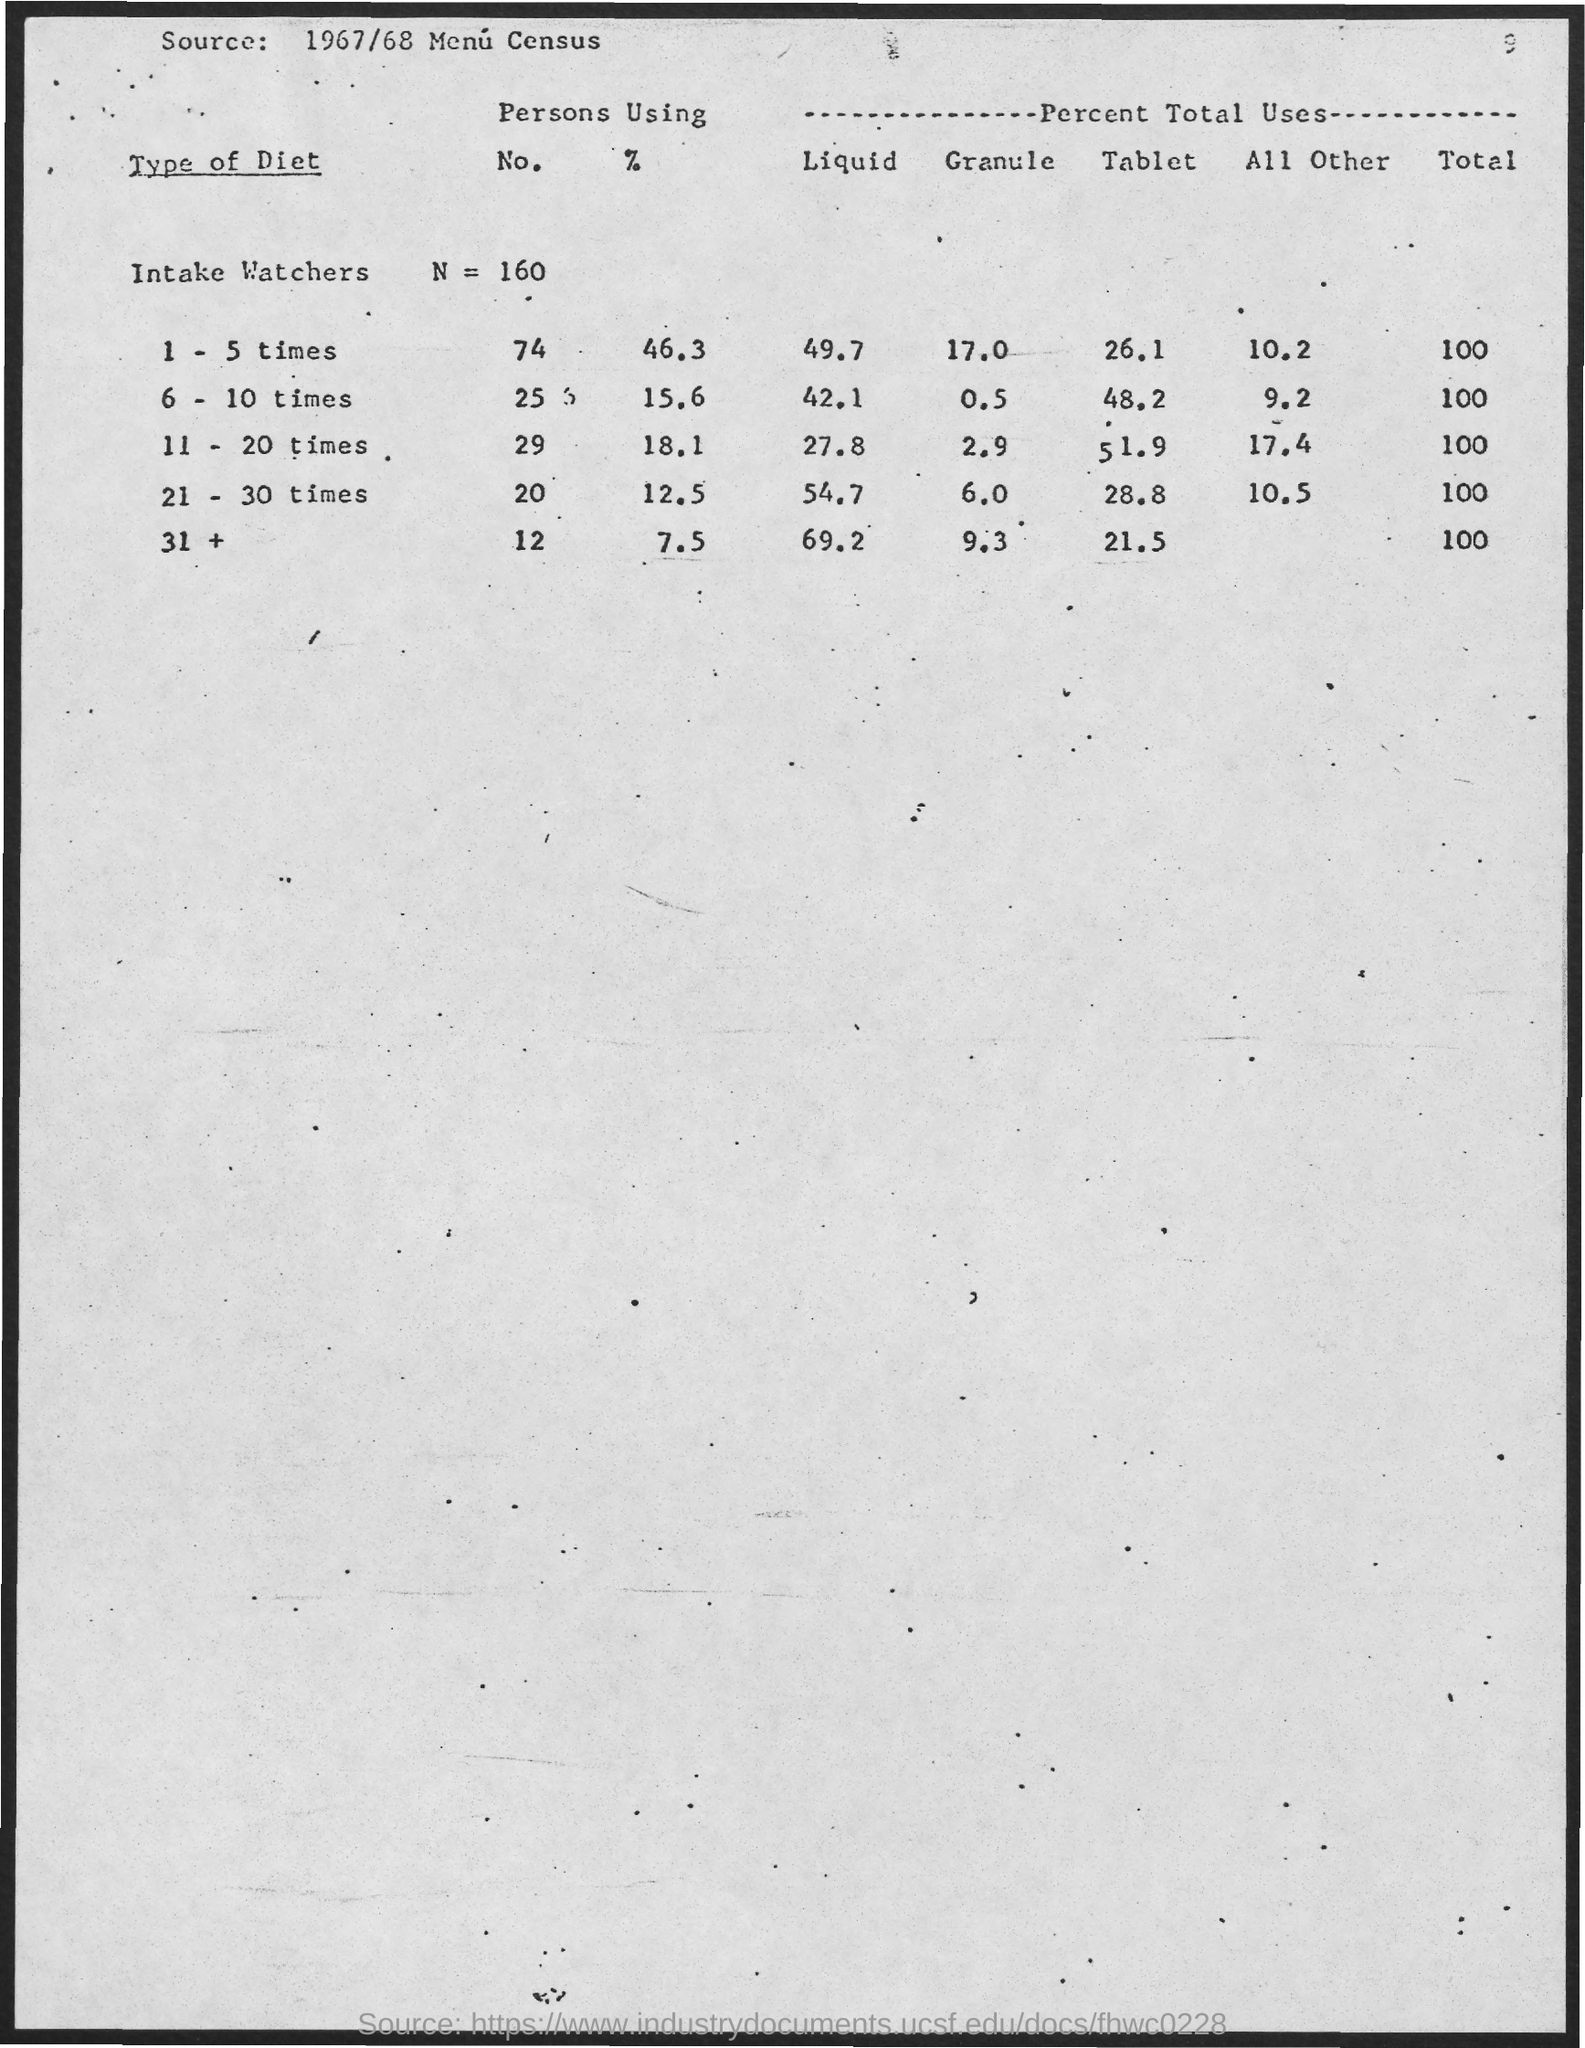What is the value of N?
Keep it short and to the point. 160. 